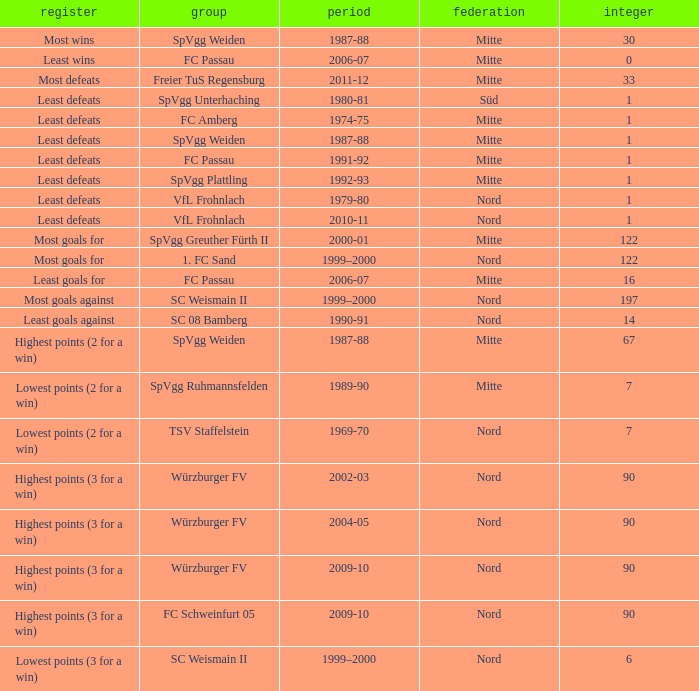Could you help me parse every detail presented in this table? {'header': ['register', 'group', 'period', 'federation', 'integer'], 'rows': [['Most wins', 'SpVgg Weiden', '1987-88', 'Mitte', '30'], ['Least wins', 'FC Passau', '2006-07', 'Mitte', '0'], ['Most defeats', 'Freier TuS Regensburg', '2011-12', 'Mitte', '33'], ['Least defeats', 'SpVgg Unterhaching', '1980-81', 'Süd', '1'], ['Least defeats', 'FC Amberg', '1974-75', 'Mitte', '1'], ['Least defeats', 'SpVgg Weiden', '1987-88', 'Mitte', '1'], ['Least defeats', 'FC Passau', '1991-92', 'Mitte', '1'], ['Least defeats', 'SpVgg Plattling', '1992-93', 'Mitte', '1'], ['Least defeats', 'VfL Frohnlach', '1979-80', 'Nord', '1'], ['Least defeats', 'VfL Frohnlach', '2010-11', 'Nord', '1'], ['Most goals for', 'SpVgg Greuther Fürth II', '2000-01', 'Mitte', '122'], ['Most goals for', '1. FC Sand', '1999–2000', 'Nord', '122'], ['Least goals for', 'FC Passau', '2006-07', 'Mitte', '16'], ['Most goals against', 'SC Weismain II', '1999–2000', 'Nord', '197'], ['Least goals against', 'SC 08 Bamberg', '1990-91', 'Nord', '14'], ['Highest points (2 for a win)', 'SpVgg Weiden', '1987-88', 'Mitte', '67'], ['Lowest points (2 for a win)', 'SpVgg Ruhmannsfelden', '1989-90', 'Mitte', '7'], ['Lowest points (2 for a win)', 'TSV Staffelstein', '1969-70', 'Nord', '7'], ['Highest points (3 for a win)', 'Würzburger FV', '2002-03', 'Nord', '90'], ['Highest points (3 for a win)', 'Würzburger FV', '2004-05', 'Nord', '90'], ['Highest points (3 for a win)', 'Würzburger FV', '2009-10', 'Nord', '90'], ['Highest points (3 for a win)', 'FC Schweinfurt 05', '2009-10', 'Nord', '90'], ['Lowest points (3 for a win)', 'SC Weismain II', '1999–2000', 'Nord', '6']]} What league has a number less than 122, and least wins as the record? Mitte. 